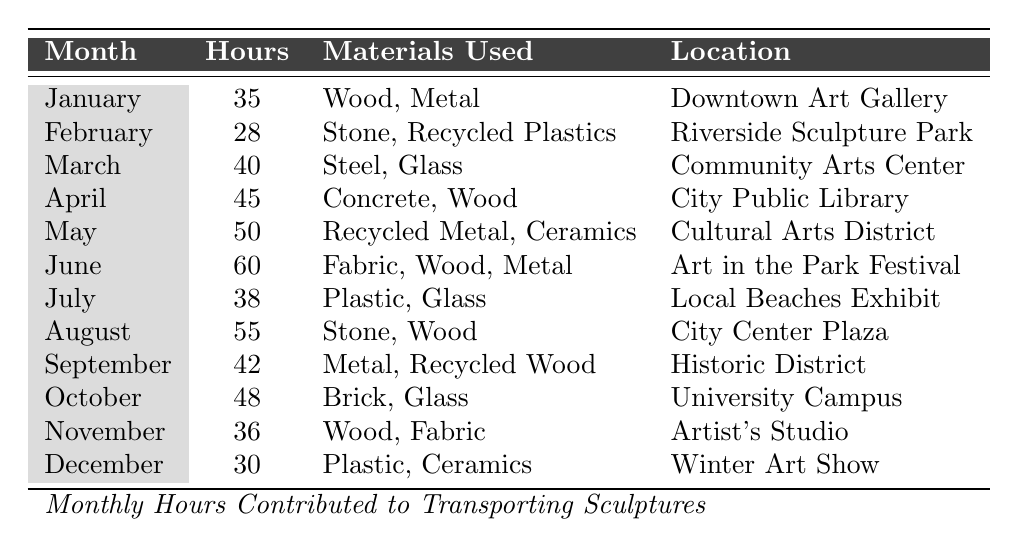What is the maximum number of hours contributed in a month? By reviewing the "Hours" column, I can identify that the maximum value is 60, which is recorded in June.
Answer: 60 Which month had the least hours contributed? Looking at the "Hours" column, February has the least contribution with 28 hours.
Answer: February How many hours were contributed in the months of June and July combined? To find the combined contributions, I add June's 60 hours and July's 38 hours: 60 + 38 = 98.
Answer: 98 Did August contribute more hours than January? August contributed 55 hours while January contributed 35 hours. Since 55 is greater than 35, the answer is yes.
Answer: Yes What is the total number of hours contributed from January to April? I will sum the hours from January (35), February (28), March (40), and April (45): 35 + 28 + 40 + 45 = 148.
Answer: 148 Which location had the highest hours contributed? By comparing the locations and their respective hours, June (Art in the Park Festival) had the highest with 60 hours.
Answer: Art in the Park Festival Is there a month where the hours contributed were identical to the number of materials used? January has 2 materials used and 35 hours, which is not identical. However, none of the months has hours equal to the number of materials. Thus, the answer is no.
Answer: No What is the average number of hours contributed per month? To find the average, I sum all the hours (35 + 28 + 40 + 45 + 50 + 60 + 38 + 55 + 42 + 48 + 36 + 30 =  508) and divide by the total number of months (12), which gives 508 / 12 = 42.33.
Answer: 42.33 In which month was more than 50 hours contributed? By reviewing the hours, I find that June (60 hours) and August (55 hours) both exceed 50 hours.
Answer: June, August How many unique materials were used in total across all months? By analyzing the materials used in each month, I find: Wood, Metal, Stone, Recycled Plastics, Steel, Glass, Concrete, Recycled Metal, Ceramics, Fabric, Plastic, and Brick. This leads to a total of 12 unique materials.
Answer: 12 